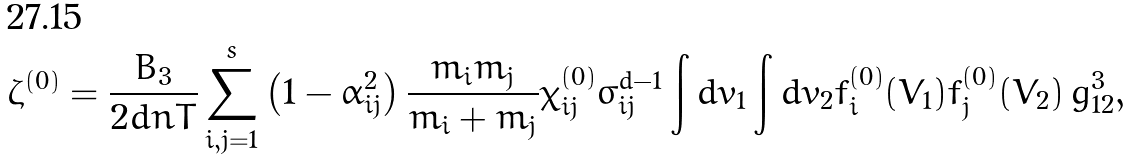<formula> <loc_0><loc_0><loc_500><loc_500>\zeta ^ { ( 0 ) } = \frac { B _ { 3 } } { 2 d n T } \sum _ { i , j = 1 } ^ { s } \left ( 1 - \alpha _ { i j } ^ { 2 } \right ) \frac { m _ { i } m _ { j } } { m _ { i } + m _ { j } } \chi _ { i j } ^ { ( 0 ) } \sigma _ { i j } ^ { d - 1 } \int d v _ { 1 } \int d v _ { 2 } f _ { i } ^ { ( 0 ) } ( V _ { 1 } ) f _ { j } ^ { ( 0 ) } ( V _ { 2 } ) \, g _ { 1 2 } ^ { 3 } ,</formula> 